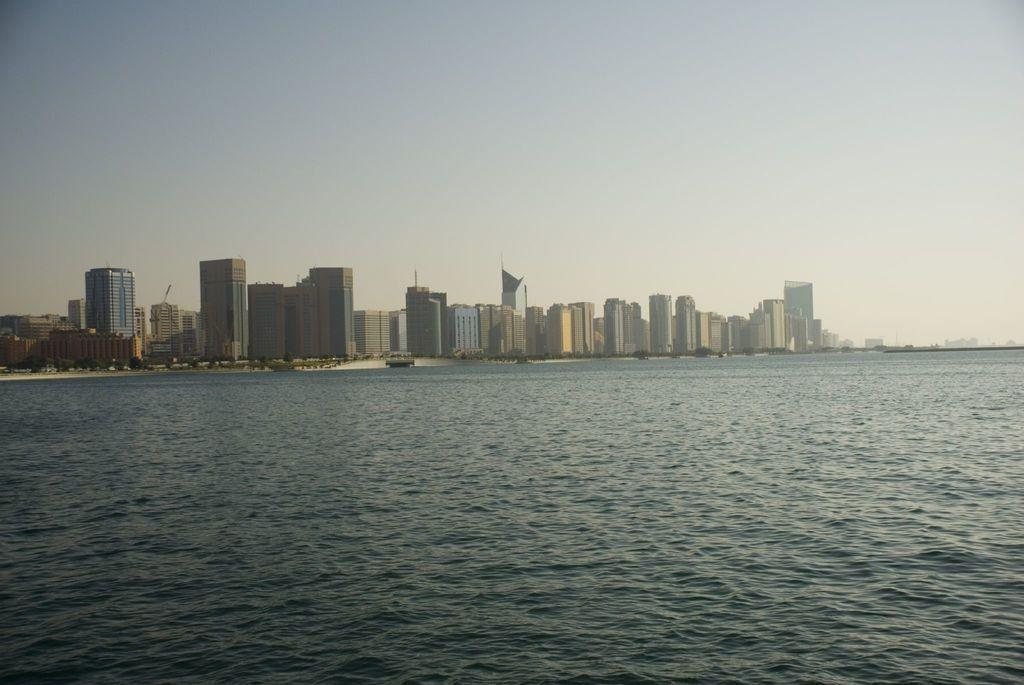What is visible in the image? Water, trees, buildings, and the sky are visible in the image. Can you describe the natural elements in the image? There are trees and water visible in the image. What type of man-made structures can be seen in the image? There are buildings in the image. What is visible in the background of the image? The sky is visible in the background of the image. How many snakes are slithering through the water in the image? There are no snakes present in the image; it features water, trees, buildings, and the sky. What type of society is depicted in the image? The image does not depict a society; it shows natural elements and man-made structures. 